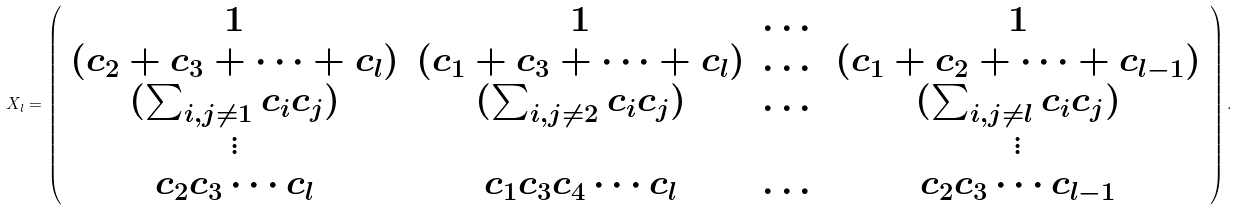Convert formula to latex. <formula><loc_0><loc_0><loc_500><loc_500>X _ { l } = \left ( \begin{array} { c c c c } 1 & 1 & \dots & 1 \\ ( c _ { 2 } + c _ { 3 } + \dots + c _ { l } ) & ( c _ { 1 } + c _ { 3 } + \dots + c _ { l } ) & \dots & ( c _ { 1 } + c _ { 2 } + \dots + c _ { l - 1 } ) \\ ( \sum _ { i , j \ne 1 } c _ { i } c _ { j } ) & ( \sum _ { i , j \ne 2 } c _ { i } c _ { j } ) & \dots & ( \sum _ { i , j \ne l } c _ { i } c _ { j } ) \\ \vdots & \, & \, & \vdots \\ c _ { 2 } c _ { 3 } \cdots c _ { l } & c _ { 1 } c _ { 3 } c _ { 4 } \cdots c _ { l } & \dots & c _ { 2 } c _ { 3 } \cdots c _ { l - 1 } \end{array} \right ) .</formula> 